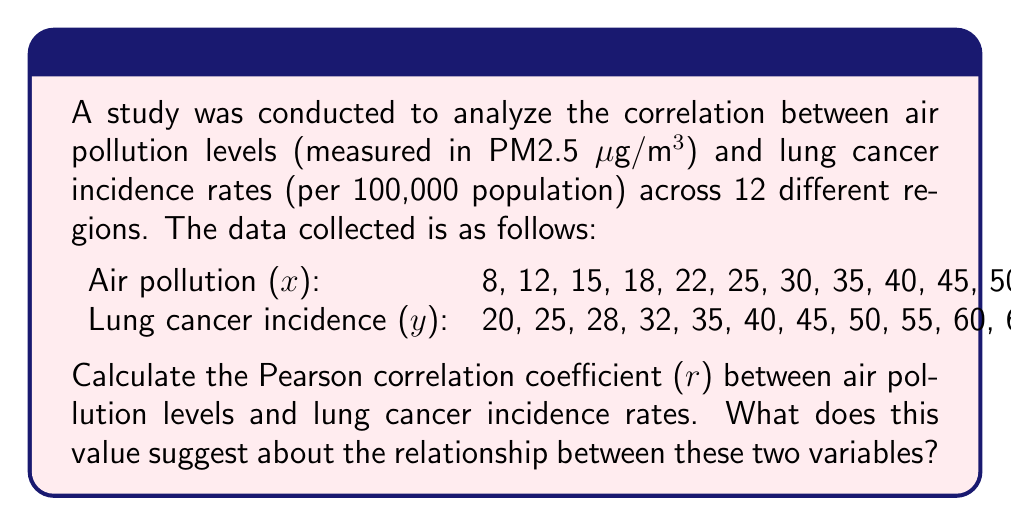Can you answer this question? To calculate the Pearson correlation coefficient (r), we'll follow these steps:

1. Calculate the means of x and y:
   $\bar{x} = \frac{\sum x}{n} = \frac{355}{12} = 29.58$
   $\bar{y} = \frac{\sum y}{n} = \frac{525}{12} = 43.75$

2. Calculate the deviations from the mean for x and y:
   $x - \bar{x}$ and $y - \bar{y}$

3. Calculate the product of these deviations:
   $(x - \bar{x})(y - \bar{y})$

4. Sum the products of deviations:
   $\sum(x - \bar{x})(y - \bar{y}) = 4744.92$

5. Calculate the sum of squared deviations for x and y:
   $\sum(x - \bar{x})^2 = 3385.92$
   $\sum(y - \bar{y})^2 = 2656.25$

6. Apply the formula for Pearson correlation coefficient:

   $$r = \frac{\sum(x - \bar{x})(y - \bar{y})}{\sqrt{\sum(x - \bar{x})^2 \sum(y - \bar{y})^2}}$$

   $$r = \frac{4744.92}{\sqrt{3385.92 \times 2656.25}} = \frac{4744.92}{2998.44} = 0.9988$$

The Pearson correlation coefficient (r) is approximately 0.9988.

This value suggests a very strong positive correlation between air pollution levels and lung cancer incidence rates. As it's very close to 1, it indicates that as air pollution levels increase, lung cancer incidence rates also increase almost linearly. This strong correlation implies that air pollution might be a significant risk factor for lung cancer in these regions.
Answer: r ≈ 0.9988; Very strong positive correlation 